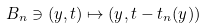Convert formula to latex. <formula><loc_0><loc_0><loc_500><loc_500>B _ { n } \ni ( y , t ) \mapsto ( y , t - t _ { n } ( y ) )</formula> 